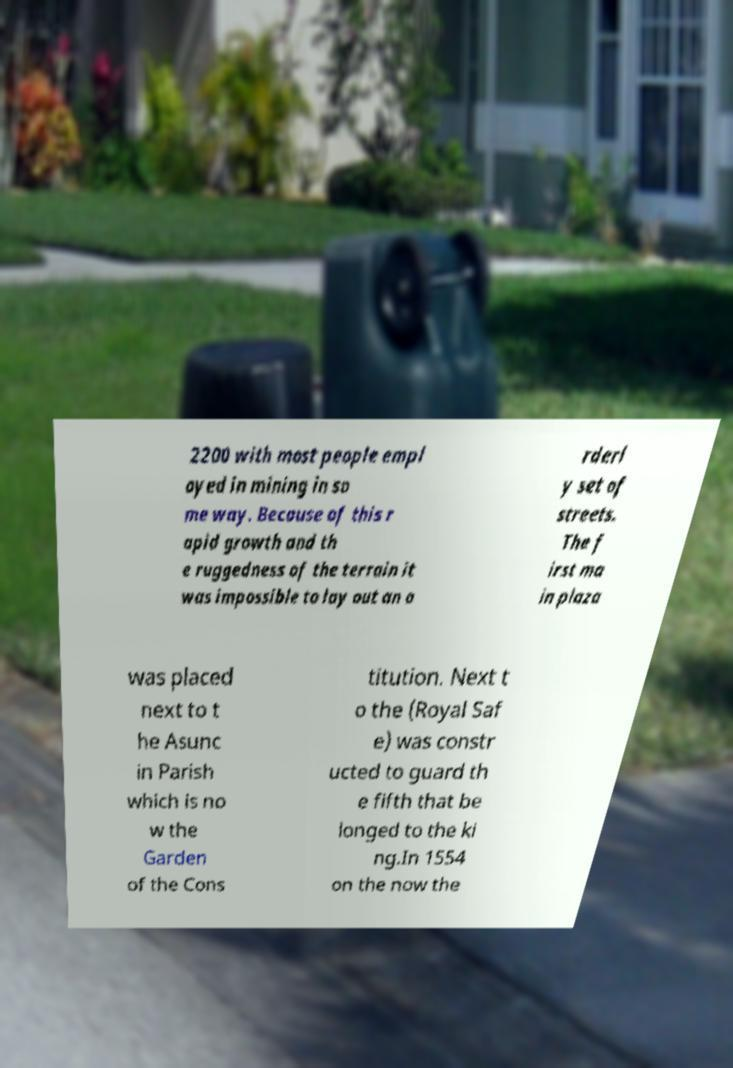Please identify and transcribe the text found in this image. 2200 with most people empl oyed in mining in so me way. Because of this r apid growth and th e ruggedness of the terrain it was impossible to lay out an o rderl y set of streets. The f irst ma in plaza was placed next to t he Asunc in Parish which is no w the Garden of the Cons titution. Next t o the (Royal Saf e) was constr ucted to guard th e fifth that be longed to the ki ng.In 1554 on the now the 